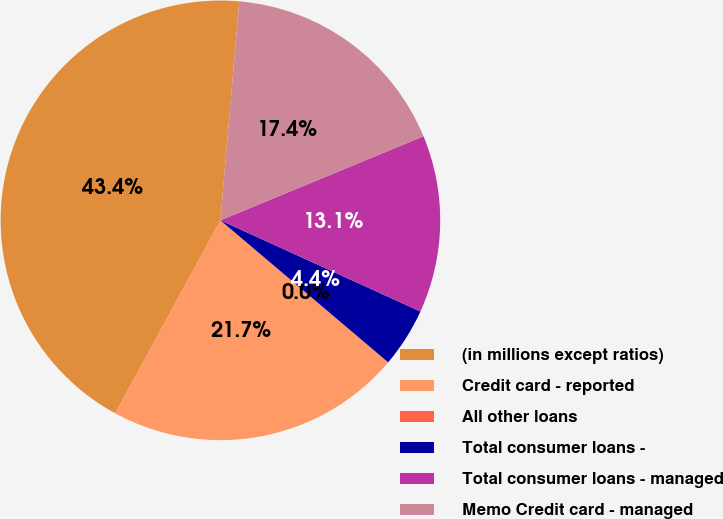Convert chart. <chart><loc_0><loc_0><loc_500><loc_500><pie_chart><fcel>(in millions except ratios)<fcel>Credit card - reported<fcel>All other loans<fcel>Total consumer loans -<fcel>Total consumer loans - managed<fcel>Memo Credit card - managed<nl><fcel>43.42%<fcel>21.73%<fcel>0.03%<fcel>4.37%<fcel>13.05%<fcel>17.39%<nl></chart> 